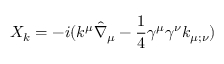<formula> <loc_0><loc_0><loc_500><loc_500>X _ { k } = - i ( k ^ { \mu } \hat { \nabla } _ { \mu } - { \frac { 1 } { 4 } } \gamma ^ { \mu } \gamma ^ { \nu } k _ { \mu ; \nu } )</formula> 